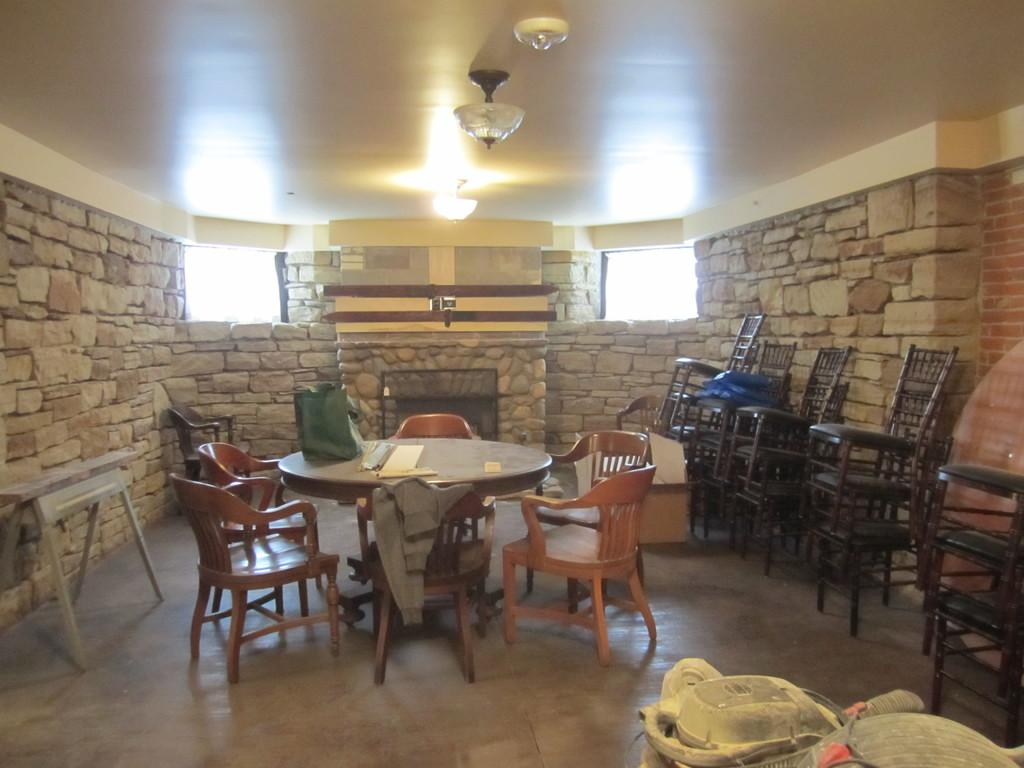What type of table is in the room? There is a round table in the room. What is the purpose of the chairs in the room? The chairs are around the table, suggesting they are for sitting and dining. How many chairs are in front of the wall? There are empty chairs in front of the wall of the room. What type of bag is hanging on the wall in the room? There is no bag present in the image; it only shows a round table, chairs, and empty chairs in front of the wall. 